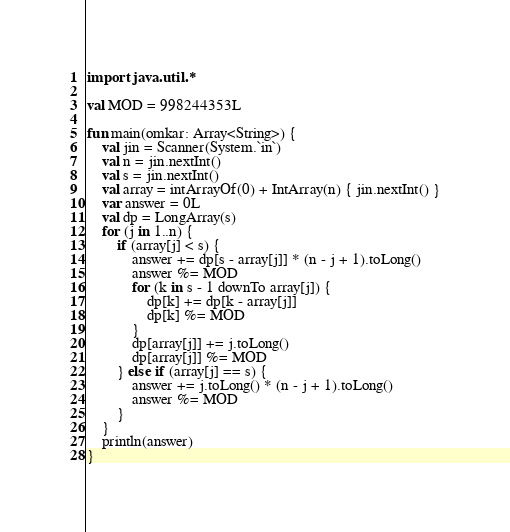Convert code to text. <code><loc_0><loc_0><loc_500><loc_500><_Kotlin_>import java.util.*

val MOD = 998244353L

fun main(omkar: Array<String>) {
    val jin = Scanner(System.`in`)
    val n = jin.nextInt()
    val s = jin.nextInt()
    val array = intArrayOf(0) + IntArray(n) { jin.nextInt() }
    var answer = 0L
    val dp = LongArray(s)
    for (j in 1..n) {
        if (array[j] < s) {
            answer += dp[s - array[j]] * (n - j + 1).toLong()
            answer %= MOD
            for (k in s - 1 downTo array[j]) {
                dp[k] += dp[k - array[j]]
                dp[k] %= MOD
            }
            dp[array[j]] += j.toLong()
            dp[array[j]] %= MOD
        } else if (array[j] == s) {
            answer += j.toLong() * (n - j + 1).toLong()
            answer %= MOD
        }
    }
    println(answer)
}</code> 